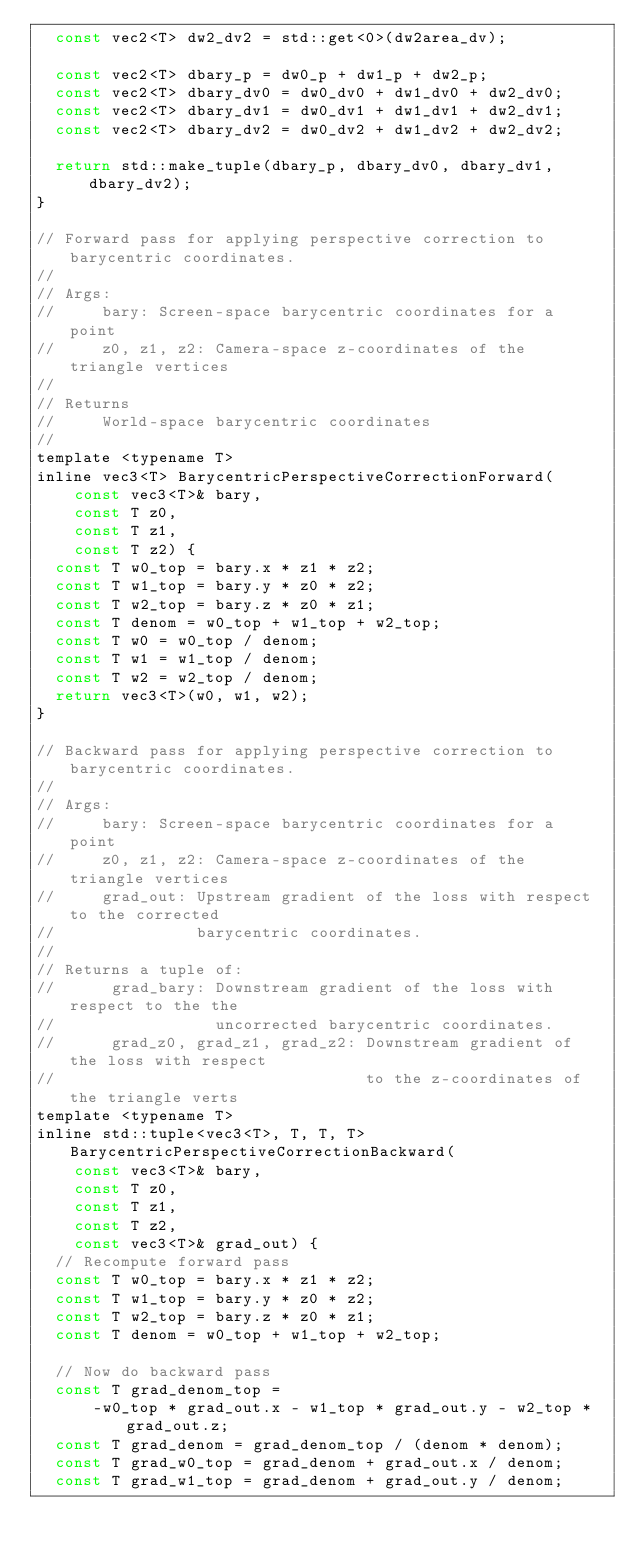Convert code to text. <code><loc_0><loc_0><loc_500><loc_500><_C_>  const vec2<T> dw2_dv2 = std::get<0>(dw2area_dv);

  const vec2<T> dbary_p = dw0_p + dw1_p + dw2_p;
  const vec2<T> dbary_dv0 = dw0_dv0 + dw1_dv0 + dw2_dv0;
  const vec2<T> dbary_dv1 = dw0_dv1 + dw1_dv1 + dw2_dv1;
  const vec2<T> dbary_dv2 = dw0_dv2 + dw1_dv2 + dw2_dv2;

  return std::make_tuple(dbary_p, dbary_dv0, dbary_dv1, dbary_dv2);
}

// Forward pass for applying perspective correction to barycentric coordinates.
//
// Args:
//     bary: Screen-space barycentric coordinates for a point
//     z0, z1, z2: Camera-space z-coordinates of the triangle vertices
//
// Returns
//     World-space barycentric coordinates
//
template <typename T>
inline vec3<T> BarycentricPerspectiveCorrectionForward(
    const vec3<T>& bary,
    const T z0,
    const T z1,
    const T z2) {
  const T w0_top = bary.x * z1 * z2;
  const T w1_top = bary.y * z0 * z2;
  const T w2_top = bary.z * z0 * z1;
  const T denom = w0_top + w1_top + w2_top;
  const T w0 = w0_top / denom;
  const T w1 = w1_top / denom;
  const T w2 = w2_top / denom;
  return vec3<T>(w0, w1, w2);
}

// Backward pass for applying perspective correction to barycentric coordinates.
//
// Args:
//     bary: Screen-space barycentric coordinates for a point
//     z0, z1, z2: Camera-space z-coordinates of the triangle vertices
//     grad_out: Upstream gradient of the loss with respect to the corrected
//               barycentric coordinates.
//
// Returns a tuple of:
//      grad_bary: Downstream gradient of the loss with respect to the the
//                 uncorrected barycentric coordinates.
//      grad_z0, grad_z1, grad_z2: Downstream gradient of the loss with respect
//                                 to the z-coordinates of the triangle verts
template <typename T>
inline std::tuple<vec3<T>, T, T, T> BarycentricPerspectiveCorrectionBackward(
    const vec3<T>& bary,
    const T z0,
    const T z1,
    const T z2,
    const vec3<T>& grad_out) {
  // Recompute forward pass
  const T w0_top = bary.x * z1 * z2;
  const T w1_top = bary.y * z0 * z2;
  const T w2_top = bary.z * z0 * z1;
  const T denom = w0_top + w1_top + w2_top;

  // Now do backward pass
  const T grad_denom_top =
      -w0_top * grad_out.x - w1_top * grad_out.y - w2_top * grad_out.z;
  const T grad_denom = grad_denom_top / (denom * denom);
  const T grad_w0_top = grad_denom + grad_out.x / denom;
  const T grad_w1_top = grad_denom + grad_out.y / denom;</code> 